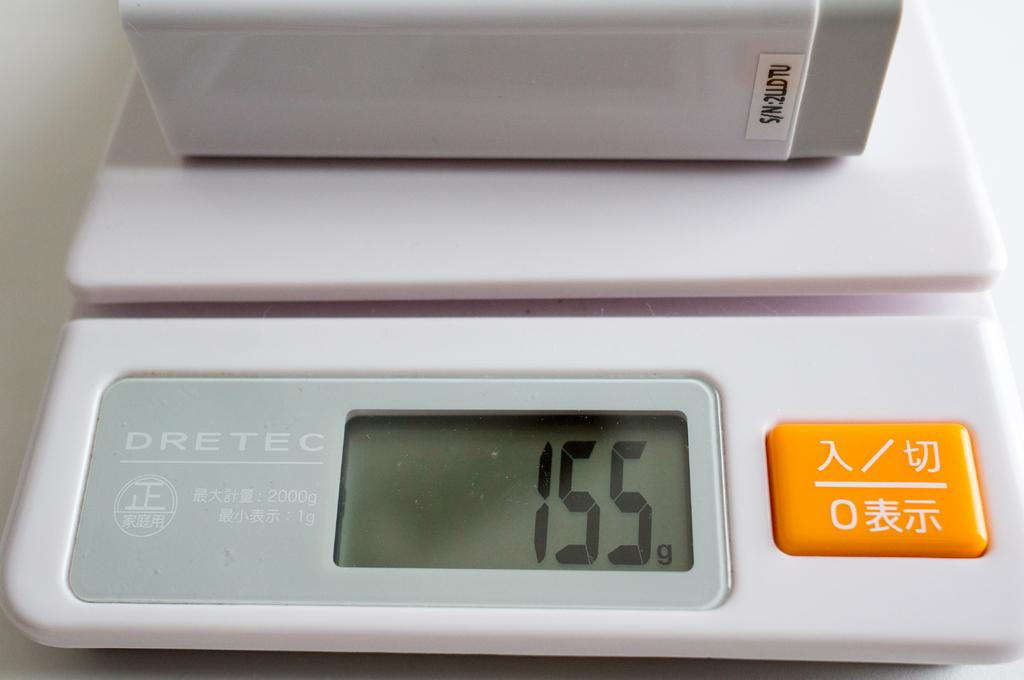What type of digital device is in the image? The image contains a digital device, but the specific type is not mentioned. What feature can be seen on the digital device? The digital device has an orange button. What type of quince is being used to press the orange button on the digital device? There is no quince present in the image, and the orange button is not being pressed by any object. 